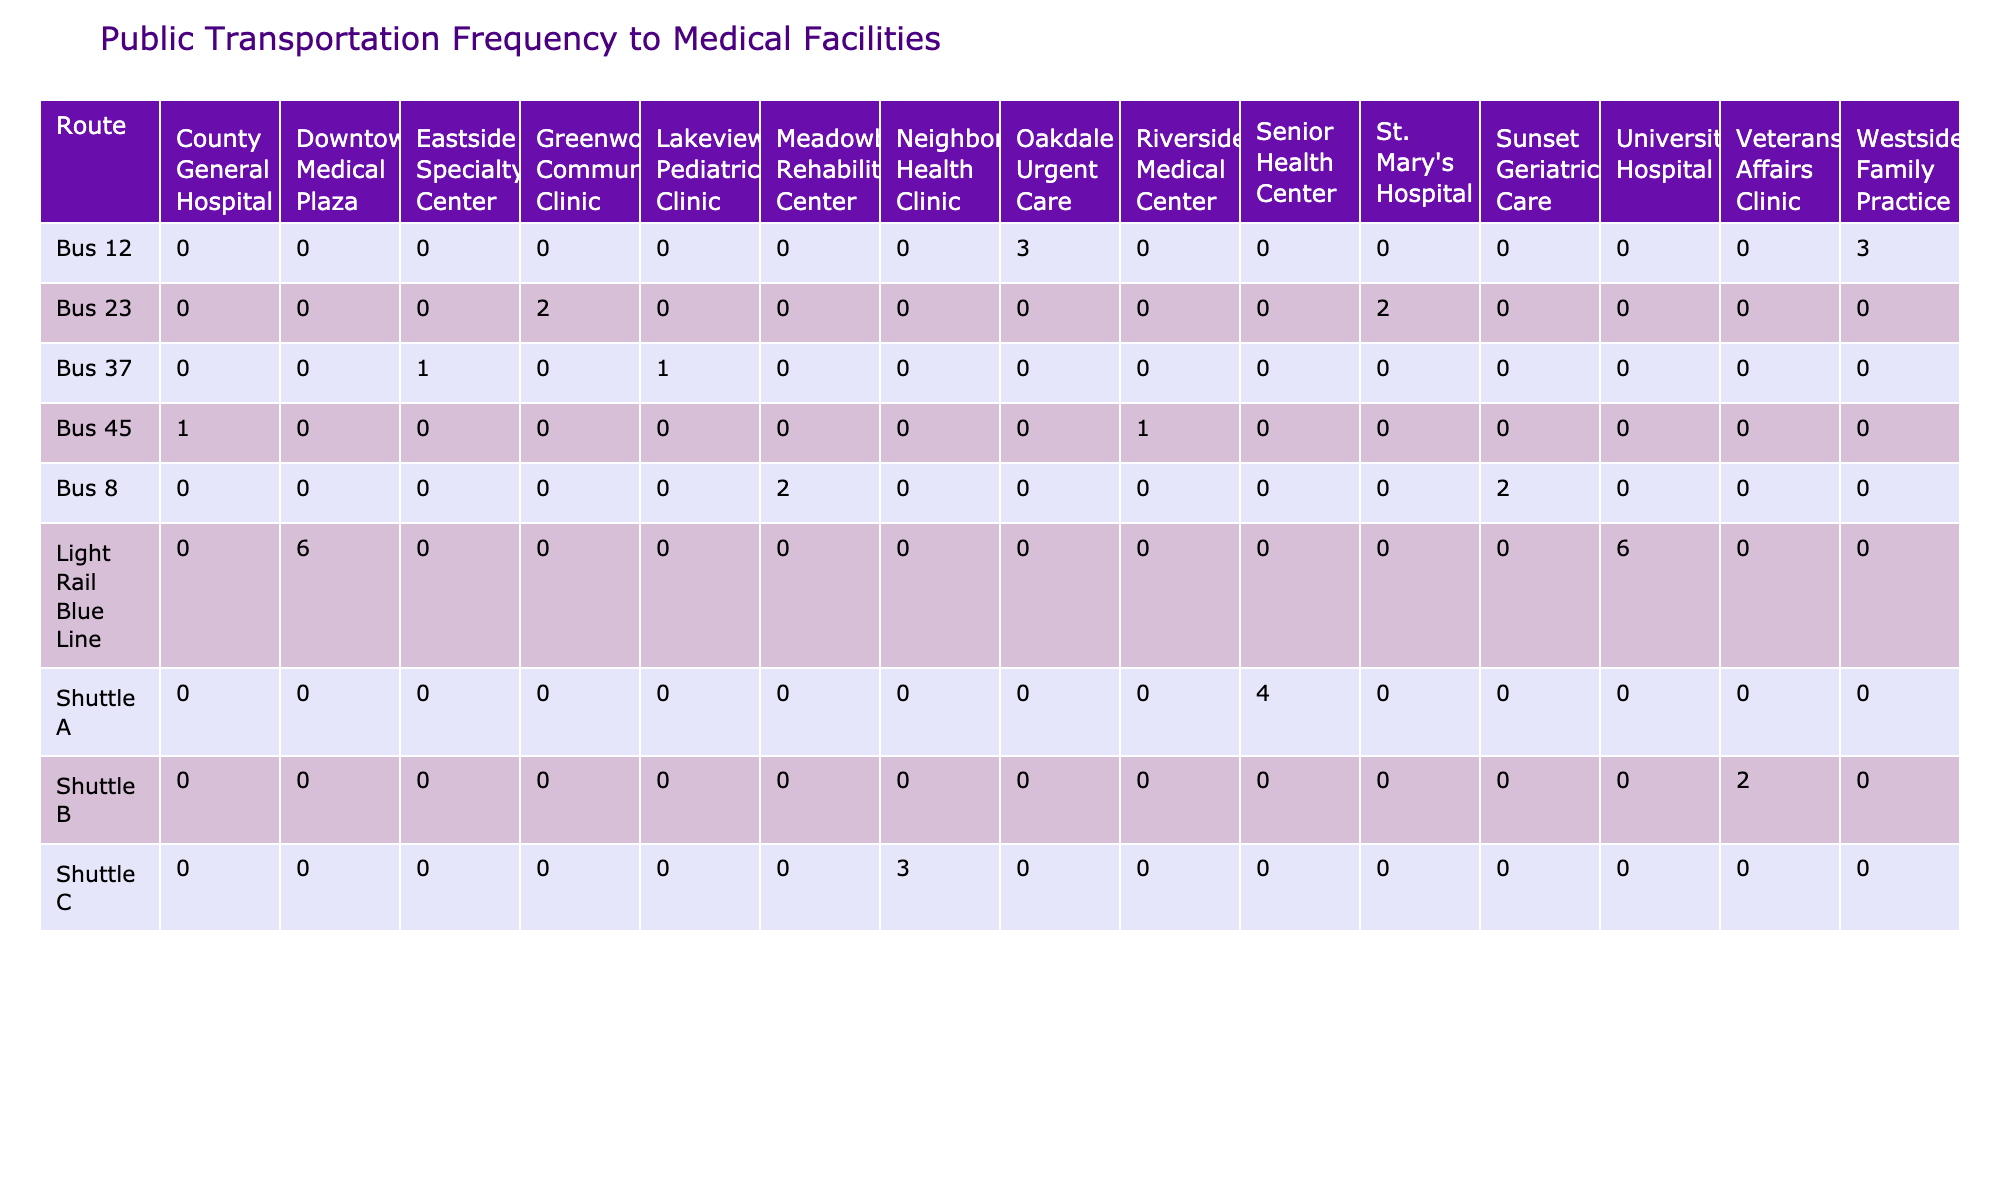What is the maximum frequency of public transportation to any medical facility listed? The highest frequency listed in the table is 6 per hour, which applies to both University Hospital and Downtown Medical Plaza.
Answer: 6 Which bus route provides the lowest frequency for medical facilities? The bus routes with the lowest frequency are Bus 45 and Bus 37, both providing a frequency of 1 per hour.
Answer: 1 Is there a medical facility served by a route that offers weekend service? Yes, many facilities, including St. Mary's Hospital and Westside Family Practice, are served by routes that offer weekend service.
Answer: Yes How many total public transportation routes serve St. Mary's Hospital? St. Mary's Hospital is served by only one route, which is Bus 23, with a frequency of 2 per hour.
Answer: 1 Which route has the highest accessibility score and what is the score? Shuttle A to Senior Health Center has the highest accessibility score of 10.
Answer: 10 What is the average frequency of all routes to medical facilities? To find the average frequency, we sum the frequencies (2 + 2 + 1 + 1 + 3 + 3 + 4 + 2 + 6 + 6 + 1 + 1 + 2 + 2 + 3) = 36, and there are 15 entries, hence the average is 36/15 = 2.4.
Answer: 2.4 Do all routes that go to the Veterans Affairs Clinic have senior discounts? No, Shuttle B to Veterans Affairs Clinic does not have senior discounts, indicating that not all routes to this facility offer discounts.
Answer: No Which medical facility has the shortest travel time from public transportation and what is that time? The Neighborhood Health Clinic via Shuttle C has the shortest travel time of just 5 minutes.
Answer: 5 What is the total distance covered by the route with the highest frequency? The route providing the highest frequency (6 per hour) is the Light Rail Blue Line; it covers a total distance of 4.9 miles to University Hospital and 5.7 miles to Downtown Medical Plaza, summing to 10.6 miles.
Answer: 10.6 